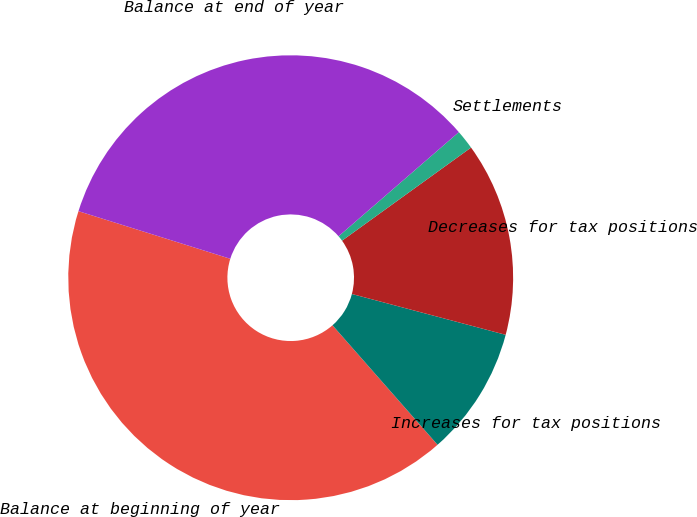<chart> <loc_0><loc_0><loc_500><loc_500><pie_chart><fcel>Balance at beginning of year<fcel>Increases for tax positions<fcel>Decreases for tax positions<fcel>Settlements<fcel>Balance at end of year<nl><fcel>41.31%<fcel>9.39%<fcel>14.08%<fcel>1.41%<fcel>33.8%<nl></chart> 